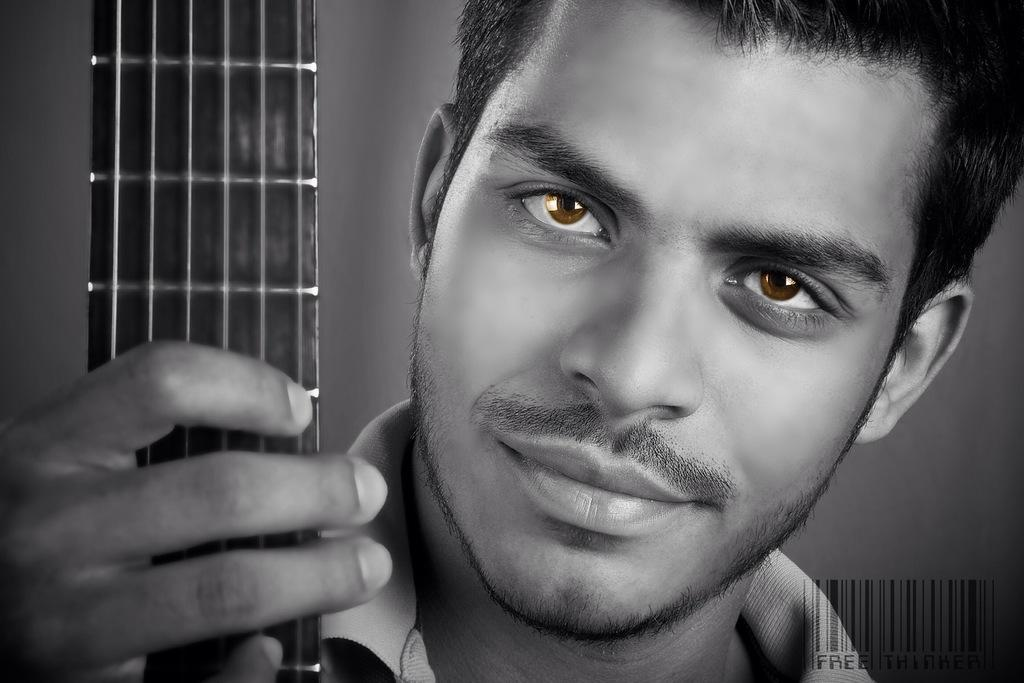What is the man in the image holding? The man is holding a guitar. What can be seen in the background of the image? There is a wall in the background of the image. What color are the man's eyes? The man's eyes are brown. What type of scissors can be seen in the image? There are no scissors present in the image. What kind of farm animals can be seen in the image? There are no farm animals present in the image. 